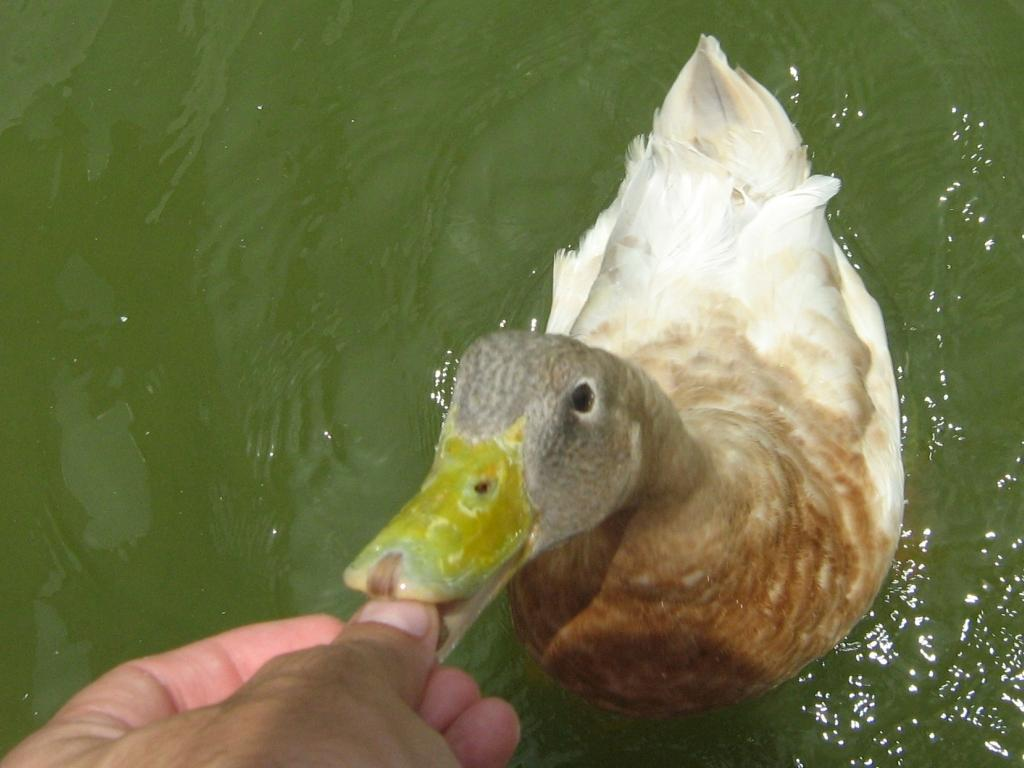Who is in the image? There is a man in the image. What is the man doing in the image? The man is feeding a duck in the image. Where is the duck located in the image? The duck is in the water in the image. How many attempts did the man make to purchase a ticket for the plane in the image? There is no mention of a ticket or a plane in the image, so it is impossible to determine the number of attempts made. 